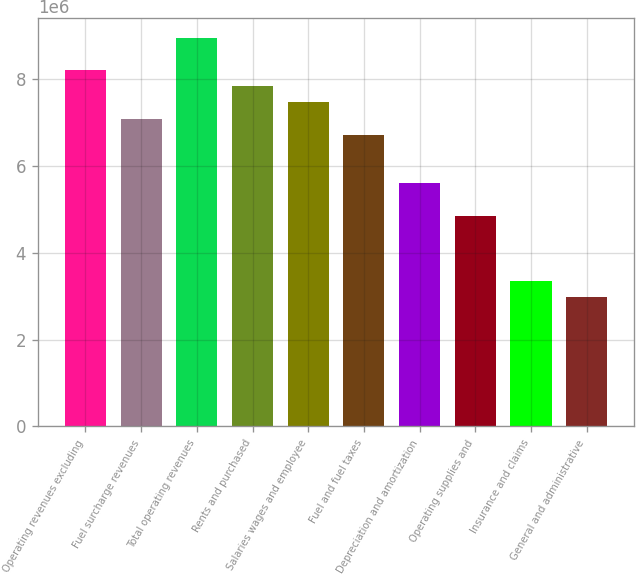Convert chart. <chart><loc_0><loc_0><loc_500><loc_500><bar_chart><fcel>Operating revenues excluding<fcel>Fuel surcharge revenues<fcel>Total operating revenues<fcel>Rents and purchased<fcel>Salaries wages and employee<fcel>Fuel and fuel taxes<fcel>Depreciation and amortization<fcel>Operating supplies and<fcel>Insurance and claims<fcel>General and administrative<nl><fcel>8.21027e+06<fcel>7.09069e+06<fcel>8.95666e+06<fcel>7.83708e+06<fcel>7.46389e+06<fcel>6.7175e+06<fcel>5.59791e+06<fcel>4.85153e+06<fcel>3.35875e+06<fcel>2.98555e+06<nl></chart> 